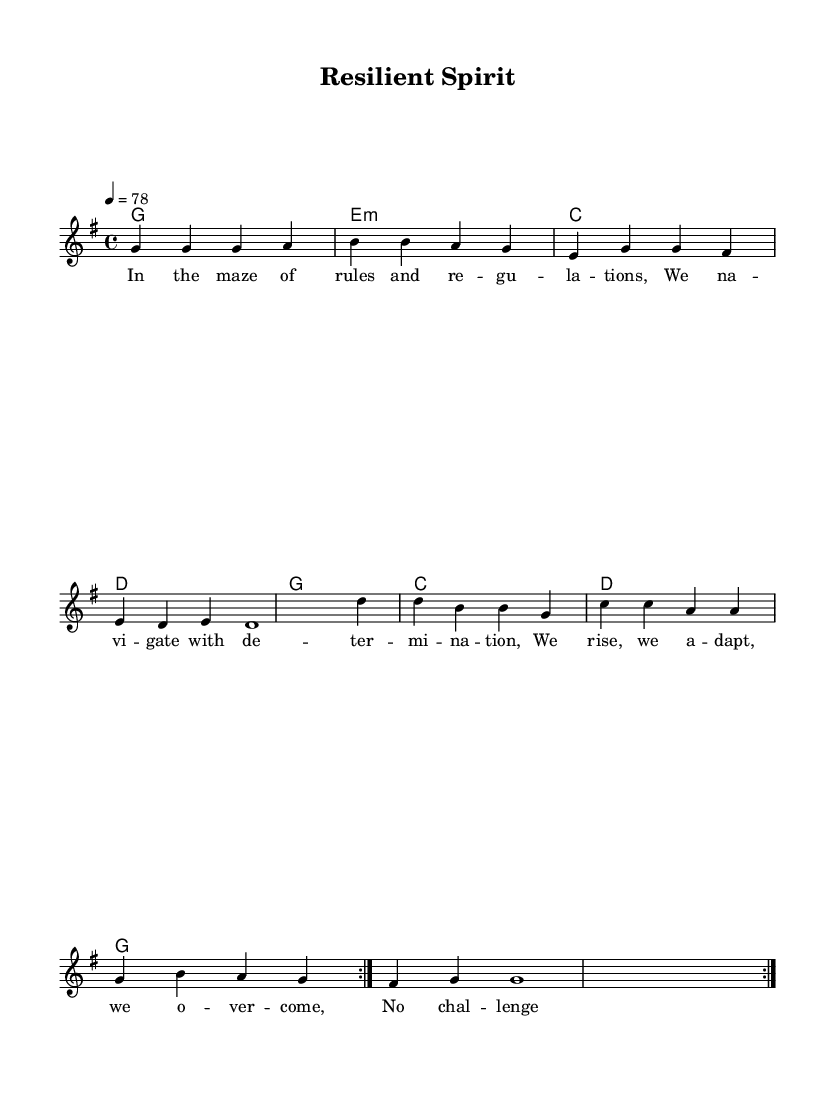What is the key signature of this music? The key signature is indicated at the beginning of the score, and it shows one sharp, which corresponds to G major.
Answer: G major What is the time signature of this music? The time signature is represented as a fraction at the beginning of the score, indicating 4 beats per measure.
Answer: 4/4 What is the tempo marking of the piece? The tempo marking states "4 = 78" at the beginning of the score, which indicates the speed of the music.
Answer: 78 How many repetitions are indicated in the melody section? The melody section includes the text "\repeat volta 2" which means the melody will be played twice.
Answer: 2 Which chord is played for the first measure? The first measure of the harmonies section shows a G major chord as indicated by the chord symbol.
Answer: G Explain the structure of the lyrics. The lyrics are divided into verses that correspond to the melody. In this piece, a single verse with 4 lines is provided. This reflects common reggae themes of resilience and perseverance in the face of challenges.
Answer: 4 lines What mood does the piece aim to convey? The lyrics and the uplifting melody combined suggest a positive and determined mood typical of reggae music, aimed at inspiring listeners through struggles.
Answer: Uplifting 